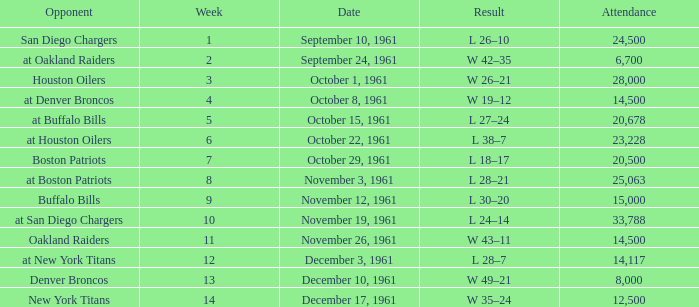What is the top attendance for weeks past 2 on october 29, 1961? 20500.0. 